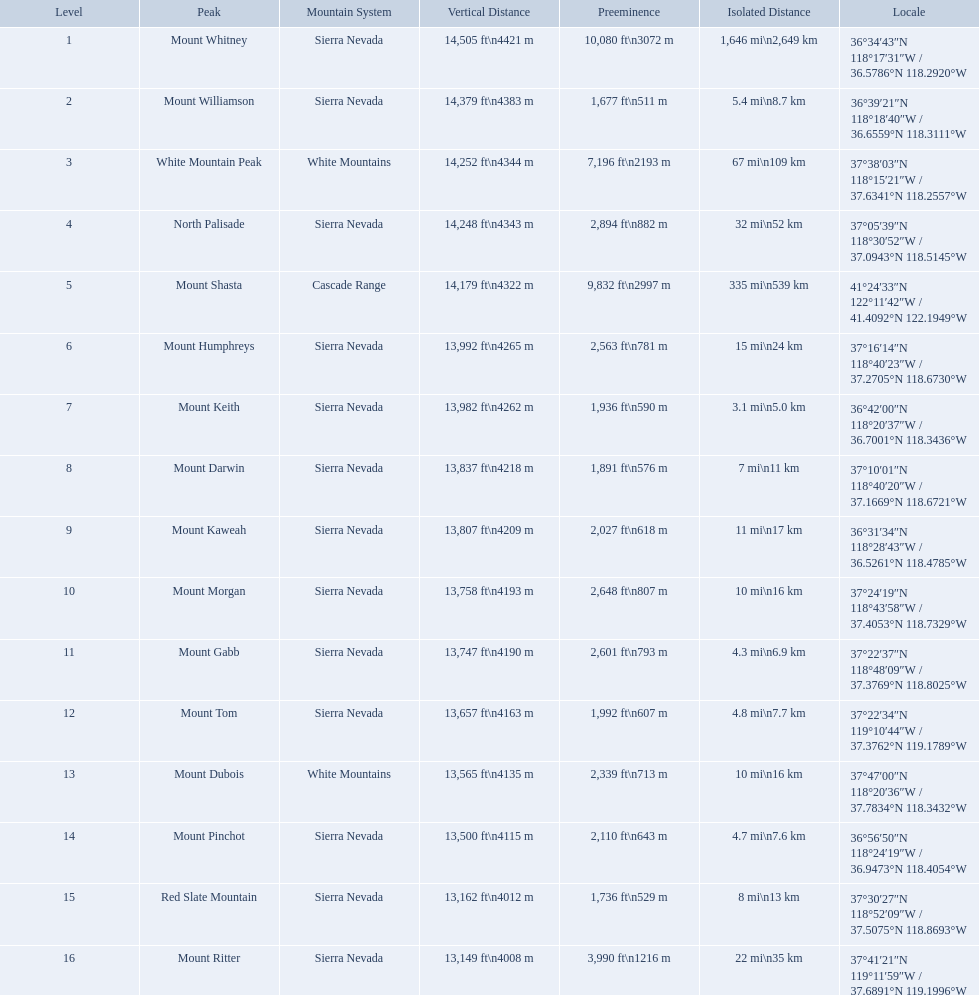What are the prominence lengths higher than 10,000 feet? 10,080 ft\n3072 m. What mountain peak has a prominence of 10,080 feet? Mount Whitney. Parse the full table in json format. {'header': ['Level', 'Peak', 'Mountain System', 'Vertical Distance', 'Preeminence', 'Isolated Distance', 'Locale'], 'rows': [['1', 'Mount Whitney', 'Sierra Nevada', '14,505\xa0ft\\n4421\xa0m', '10,080\xa0ft\\n3072\xa0m', '1,646\xa0mi\\n2,649\xa0km', '36°34′43″N 118°17′31″W\ufeff / \ufeff36.5786°N 118.2920°W'], ['2', 'Mount Williamson', 'Sierra Nevada', '14,379\xa0ft\\n4383\xa0m', '1,677\xa0ft\\n511\xa0m', '5.4\xa0mi\\n8.7\xa0km', '36°39′21″N 118°18′40″W\ufeff / \ufeff36.6559°N 118.3111°W'], ['3', 'White Mountain Peak', 'White Mountains', '14,252\xa0ft\\n4344\xa0m', '7,196\xa0ft\\n2193\xa0m', '67\xa0mi\\n109\xa0km', '37°38′03″N 118°15′21″W\ufeff / \ufeff37.6341°N 118.2557°W'], ['4', 'North Palisade', 'Sierra Nevada', '14,248\xa0ft\\n4343\xa0m', '2,894\xa0ft\\n882\xa0m', '32\xa0mi\\n52\xa0km', '37°05′39″N 118°30′52″W\ufeff / \ufeff37.0943°N 118.5145°W'], ['5', 'Mount Shasta', 'Cascade Range', '14,179\xa0ft\\n4322\xa0m', '9,832\xa0ft\\n2997\xa0m', '335\xa0mi\\n539\xa0km', '41°24′33″N 122°11′42″W\ufeff / \ufeff41.4092°N 122.1949°W'], ['6', 'Mount Humphreys', 'Sierra Nevada', '13,992\xa0ft\\n4265\xa0m', '2,563\xa0ft\\n781\xa0m', '15\xa0mi\\n24\xa0km', '37°16′14″N 118°40′23″W\ufeff / \ufeff37.2705°N 118.6730°W'], ['7', 'Mount Keith', 'Sierra Nevada', '13,982\xa0ft\\n4262\xa0m', '1,936\xa0ft\\n590\xa0m', '3.1\xa0mi\\n5.0\xa0km', '36°42′00″N 118°20′37″W\ufeff / \ufeff36.7001°N 118.3436°W'], ['8', 'Mount Darwin', 'Sierra Nevada', '13,837\xa0ft\\n4218\xa0m', '1,891\xa0ft\\n576\xa0m', '7\xa0mi\\n11\xa0km', '37°10′01″N 118°40′20″W\ufeff / \ufeff37.1669°N 118.6721°W'], ['9', 'Mount Kaweah', 'Sierra Nevada', '13,807\xa0ft\\n4209\xa0m', '2,027\xa0ft\\n618\xa0m', '11\xa0mi\\n17\xa0km', '36°31′34″N 118°28′43″W\ufeff / \ufeff36.5261°N 118.4785°W'], ['10', 'Mount Morgan', 'Sierra Nevada', '13,758\xa0ft\\n4193\xa0m', '2,648\xa0ft\\n807\xa0m', '10\xa0mi\\n16\xa0km', '37°24′19″N 118°43′58″W\ufeff / \ufeff37.4053°N 118.7329°W'], ['11', 'Mount Gabb', 'Sierra Nevada', '13,747\xa0ft\\n4190\xa0m', '2,601\xa0ft\\n793\xa0m', '4.3\xa0mi\\n6.9\xa0km', '37°22′37″N 118°48′09″W\ufeff / \ufeff37.3769°N 118.8025°W'], ['12', 'Mount Tom', 'Sierra Nevada', '13,657\xa0ft\\n4163\xa0m', '1,992\xa0ft\\n607\xa0m', '4.8\xa0mi\\n7.7\xa0km', '37°22′34″N 119°10′44″W\ufeff / \ufeff37.3762°N 119.1789°W'], ['13', 'Mount Dubois', 'White Mountains', '13,565\xa0ft\\n4135\xa0m', '2,339\xa0ft\\n713\xa0m', '10\xa0mi\\n16\xa0km', '37°47′00″N 118°20′36″W\ufeff / \ufeff37.7834°N 118.3432°W'], ['14', 'Mount Pinchot', 'Sierra Nevada', '13,500\xa0ft\\n4115\xa0m', '2,110\xa0ft\\n643\xa0m', '4.7\xa0mi\\n7.6\xa0km', '36°56′50″N 118°24′19″W\ufeff / \ufeff36.9473°N 118.4054°W'], ['15', 'Red Slate Mountain', 'Sierra Nevada', '13,162\xa0ft\\n4012\xa0m', '1,736\xa0ft\\n529\xa0m', '8\xa0mi\\n13\xa0km', '37°30′27″N 118°52′09″W\ufeff / \ufeff37.5075°N 118.8693°W'], ['16', 'Mount Ritter', 'Sierra Nevada', '13,149\xa0ft\\n4008\xa0m', '3,990\xa0ft\\n1216\xa0m', '22\xa0mi\\n35\xa0km', '37°41′21″N 119°11′59″W\ufeff / \ufeff37.6891°N 119.1996°W']]} What are the peaks in california? Mount Whitney, Mount Williamson, White Mountain Peak, North Palisade, Mount Shasta, Mount Humphreys, Mount Keith, Mount Darwin, Mount Kaweah, Mount Morgan, Mount Gabb, Mount Tom, Mount Dubois, Mount Pinchot, Red Slate Mountain, Mount Ritter. What are the peaks in sierra nevada, california? Mount Whitney, Mount Williamson, North Palisade, Mount Humphreys, Mount Keith, Mount Darwin, Mount Kaweah, Mount Morgan, Mount Gabb, Mount Tom, Mount Pinchot, Red Slate Mountain, Mount Ritter. What are the heights of the peaks in sierra nevada? 14,505 ft\n4421 m, 14,379 ft\n4383 m, 14,248 ft\n4343 m, 13,992 ft\n4265 m, 13,982 ft\n4262 m, 13,837 ft\n4218 m, 13,807 ft\n4209 m, 13,758 ft\n4193 m, 13,747 ft\n4190 m, 13,657 ft\n4163 m, 13,500 ft\n4115 m, 13,162 ft\n4012 m, 13,149 ft\n4008 m. Which is the highest? Mount Whitney. What mountain peak is listed for the sierra nevada mountain range? Mount Whitney. What mountain peak has an elevation of 14,379ft? Mount Williamson. Which mountain is listed for the cascade range? Mount Shasta. What are all of the mountain peaks? Mount Whitney, Mount Williamson, White Mountain Peak, North Palisade, Mount Shasta, Mount Humphreys, Mount Keith, Mount Darwin, Mount Kaweah, Mount Morgan, Mount Gabb, Mount Tom, Mount Dubois, Mount Pinchot, Red Slate Mountain, Mount Ritter. In what ranges are they located? Sierra Nevada, Sierra Nevada, White Mountains, Sierra Nevada, Cascade Range, Sierra Nevada, Sierra Nevada, Sierra Nevada, Sierra Nevada, Sierra Nevada, Sierra Nevada, Sierra Nevada, White Mountains, Sierra Nevada, Sierra Nevada, Sierra Nevada. And which mountain peak is in the cascade range? Mount Shasta. Which are the highest mountain peaks in california? Mount Whitney, Mount Williamson, White Mountain Peak, North Palisade, Mount Shasta, Mount Humphreys, Mount Keith, Mount Darwin, Mount Kaweah, Mount Morgan, Mount Gabb, Mount Tom, Mount Dubois, Mount Pinchot, Red Slate Mountain, Mount Ritter. Of those, which are not in the sierra nevada range? White Mountain Peak, Mount Shasta, Mount Dubois. Of the mountains not in the sierra nevada range, which is the only mountain in the cascades? Mount Shasta. 